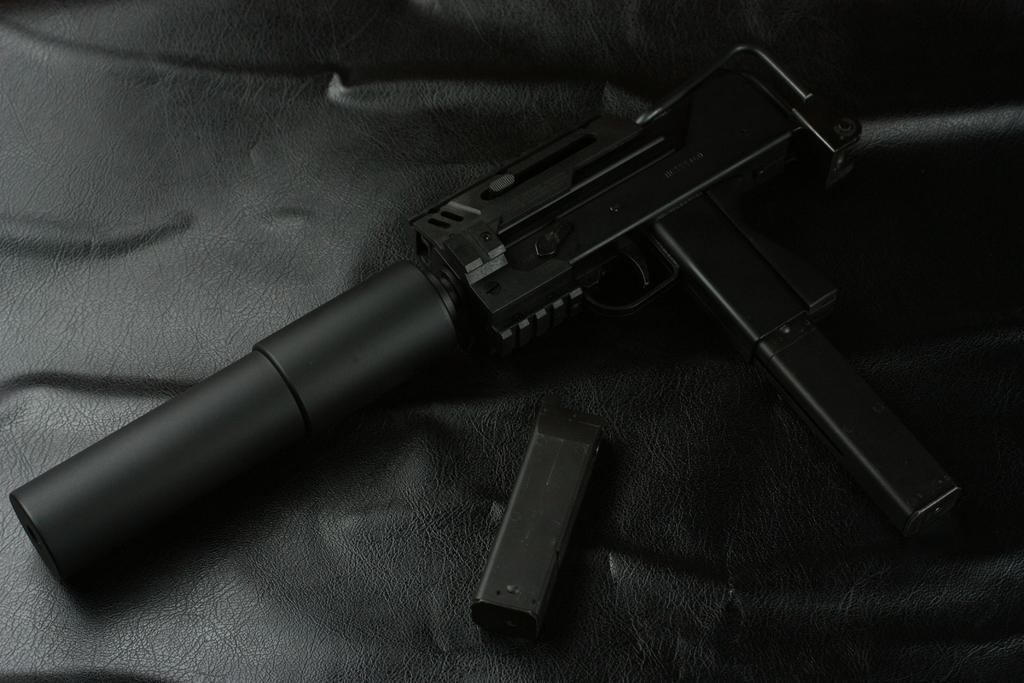What is the color scheme of the image? The image is black and white. What objects can be seen in the image? There is a gun and a magazine in the image. What material is the floor made of in the image? The floor in the image is made of leather. What type of day is depicted in the image? The image is black and white, so it does not depict a specific day or time of day. What experience can be gained from the image? The image is a still image, so it does not offer an experience or interaction. 